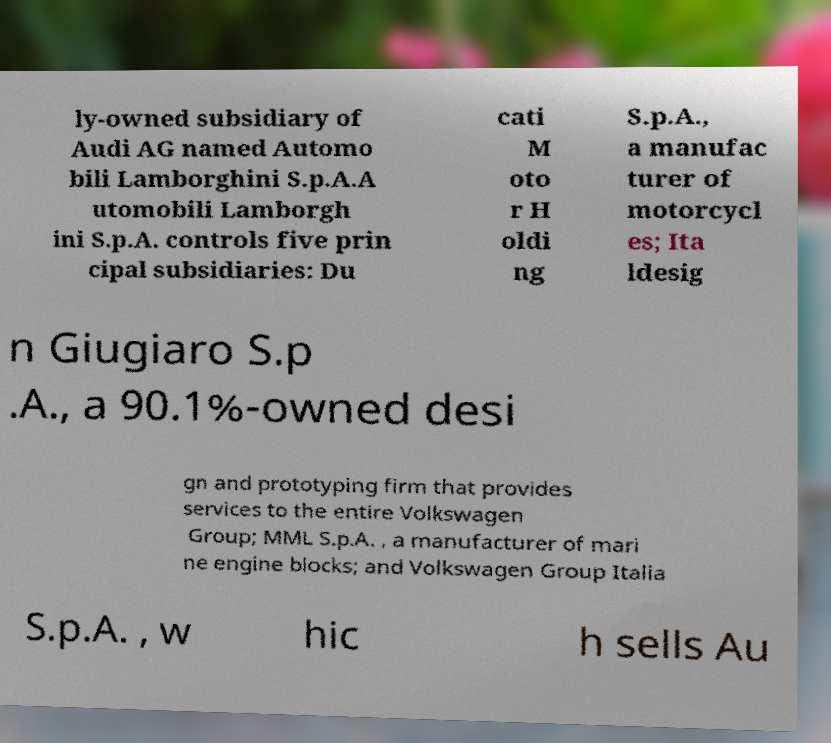I need the written content from this picture converted into text. Can you do that? ly-owned subsidiary of Audi AG named Automo bili Lamborghini S.p.A.A utomobili Lamborgh ini S.p.A. controls five prin cipal subsidiaries: Du cati M oto r H oldi ng S.p.A., a manufac turer of motorcycl es; Ita ldesig n Giugiaro S.p .A., a 90.1%-owned desi gn and prototyping firm that provides services to the entire Volkswagen Group; MML S.p.A. , a manufacturer of mari ne engine blocks; and Volkswagen Group Italia S.p.A. , w hic h sells Au 